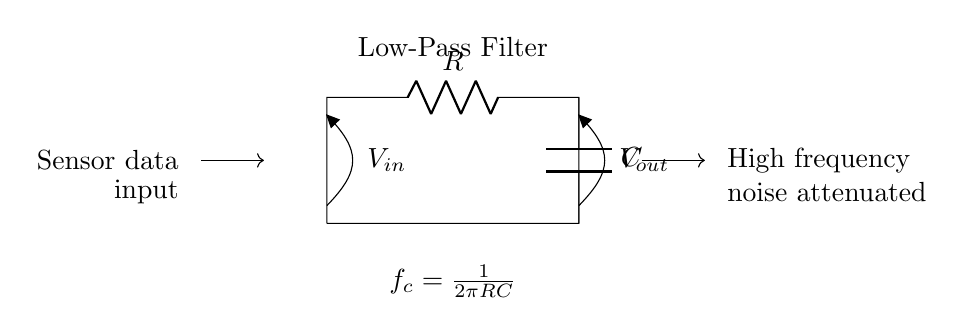What components are used in this circuit? The circuit consists of a resistor and a capacitor, as labeled in the diagram. The resistor is marked with R and the capacitor with C.
Answer: Resistor and Capacitor What is the function of the circuit? The circuit is identified as a low-pass filter, which allows low-frequency signals to pass while attenuating high-frequency noise. The function is indicated in the node label.
Answer: Low-pass filter What is the cutoff frequency formula provided? The cutoff frequency is given as \( f_c = \frac{1}{2\pi RC} \), which relates to the values of the resistor and capacitor in determining the frequency where the output begins to be attenuated.
Answer: f_c = 1/2πRC What type of filter is represented in the circuit? The circuit specifically represents a low-pass filter, as indicated by the open input and output connections labeled for sensor data and output voltage.
Answer: Low-pass filter How does high-frequency noise behave in this circuit? High-frequency noise is attenuated, meaning it is reduced in amplitude as it passes through the circuit. The circuit is designed to minimize the effect of such noise on the signal being processed.
Answer: Attenuated If the resistance is doubled, what happens to the cutoff frequency? If the resistance (R) is doubled, the cutoff frequency \( f_c \) decreases, as \( f_c \) is inversely proportional to R in the formula \( f_c = \frac{1}{2\pi RC} \).
Answer: Decreases What happens to the output voltage when the input is high-frequency noise? When the input is high-frequency noise, the output voltage decreases significantly due to the low-pass filter's function to attenuate these frequencies, resulting in a cleaner signal.
Answer: Decreases 